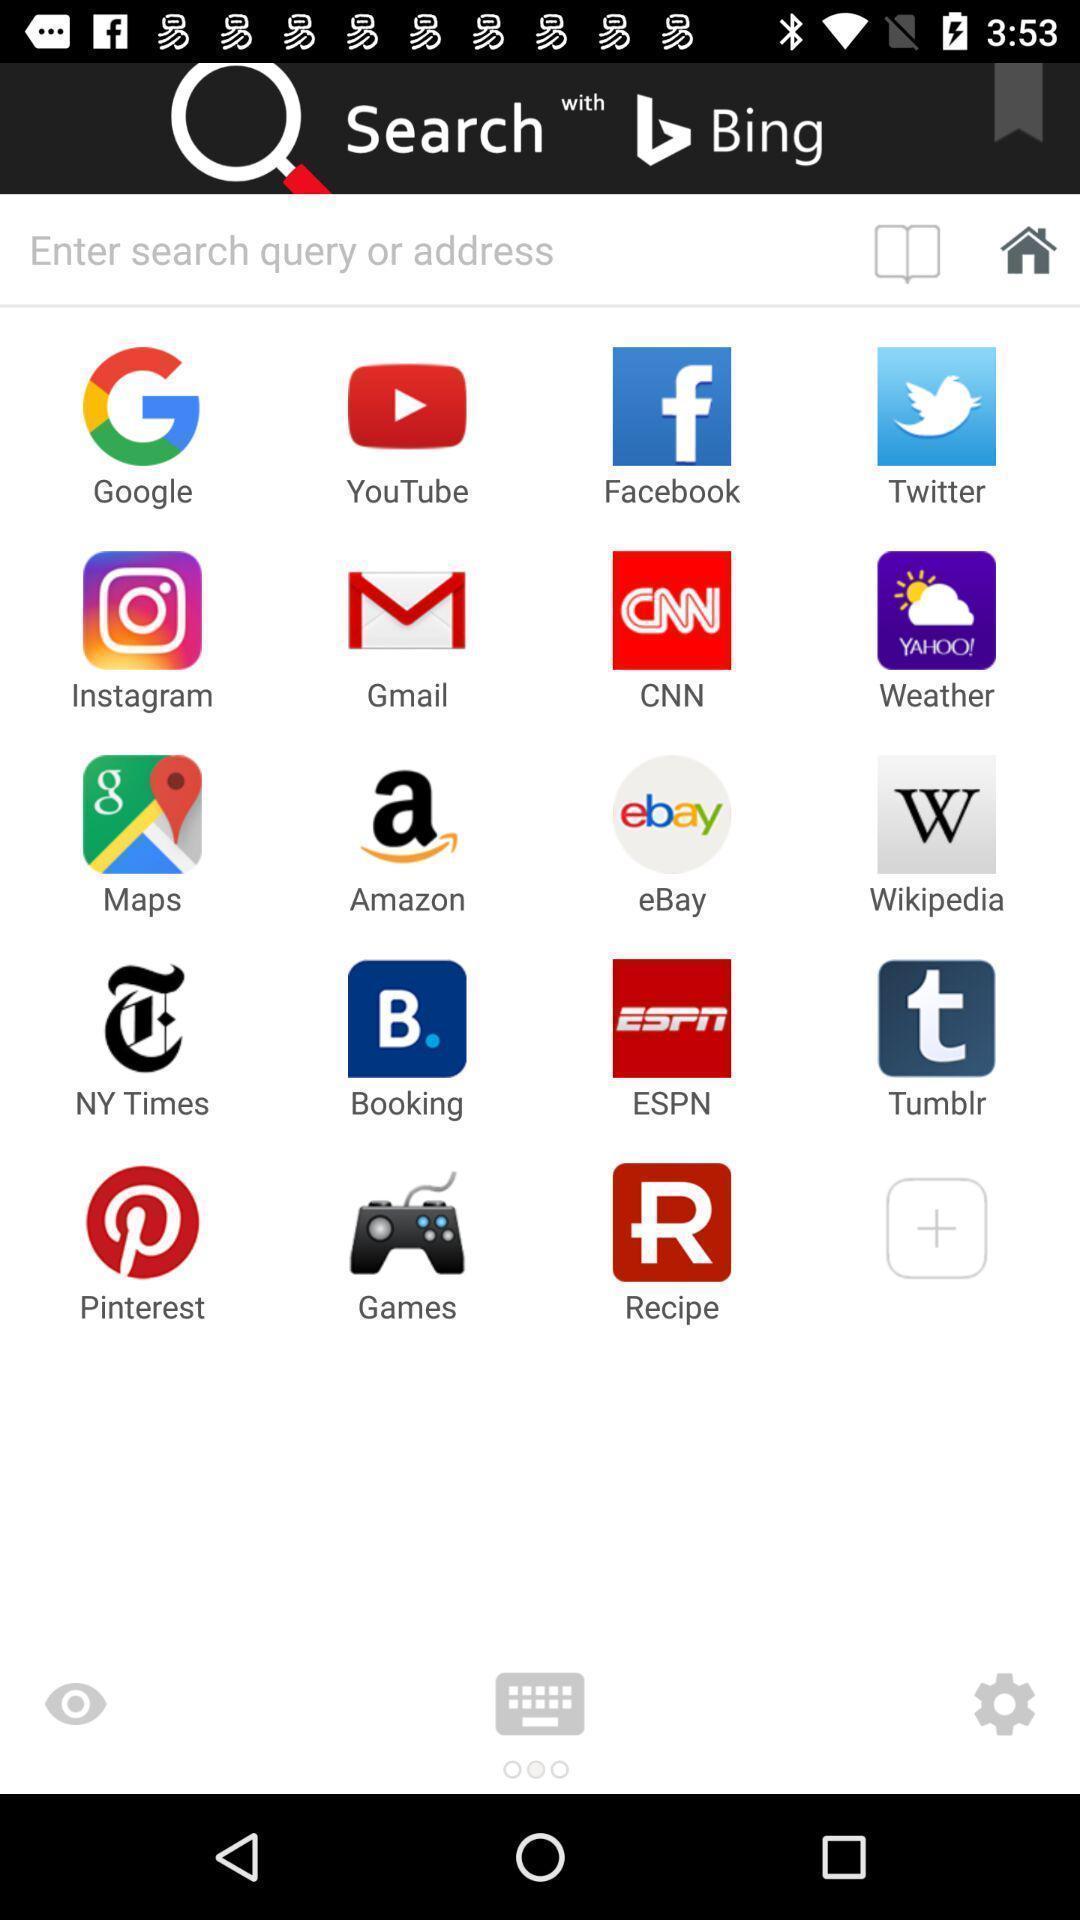Please provide a description for this image. Page with a search bar in a browser. 